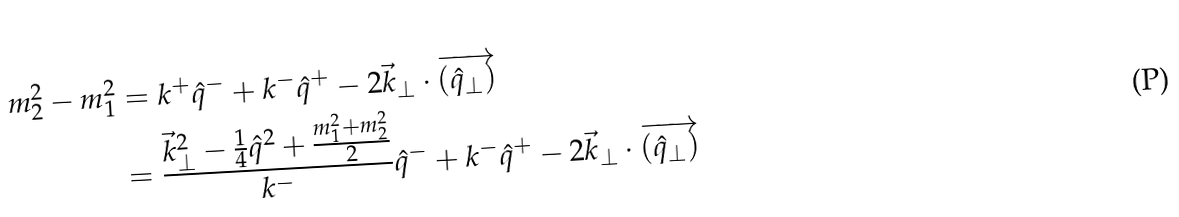Convert formula to latex. <formula><loc_0><loc_0><loc_500><loc_500>m _ { 2 } ^ { 2 } - m _ { 1 } ^ { 2 } & = k ^ { + } \hat { q } ^ { - } + k ^ { - } \hat { q } ^ { + } - 2 \vec { k } _ { \perp } \cdot \overrightarrow { ( \hat { q } _ { \perp } ) } \\ & = \frac { \vec { k } _ { \perp } ^ { 2 } - \frac { 1 } { 4 } \hat { q } ^ { 2 } + \frac { m _ { 1 } ^ { 2 } + m _ { 2 } ^ { 2 } } { 2 } } { k ^ { - } } \hat { q } ^ { - } + k ^ { - } \hat { q } ^ { + } - 2 \vec { k } _ { \perp } \cdot \overrightarrow { ( \hat { q } _ { \perp } ) }</formula> 